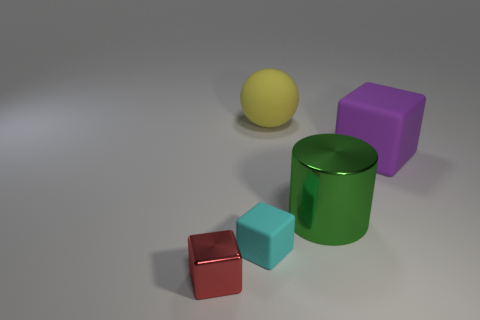Do the rubber cube behind the green shiny cylinder and the shiny object to the left of the yellow thing have the same color?
Keep it short and to the point. No. Is there a tiny cyan object on the right side of the cube that is to the right of the cylinder?
Your response must be concise. No. Does the thing behind the big purple cube have the same shape as the thing that is right of the large green metallic object?
Your answer should be compact. No. Does the tiny thing that is behind the small red object have the same material as the small red cube in front of the purple rubber thing?
Ensure brevity in your answer.  No. The block to the right of the big rubber object behind the large purple thing is made of what material?
Your answer should be very brief. Rubber. What shape is the large rubber thing left of the metallic thing behind the small object right of the red metallic object?
Keep it short and to the point. Sphere. There is a cyan thing that is the same shape as the purple rubber thing; what is its material?
Keep it short and to the point. Rubber. What number of big yellow objects are there?
Provide a succinct answer. 1. There is a tiny thing right of the red object; what is its shape?
Your answer should be compact. Cube. There is a rubber cube that is behind the shiny thing that is behind the metal thing to the left of the big ball; what color is it?
Provide a succinct answer. Purple. 